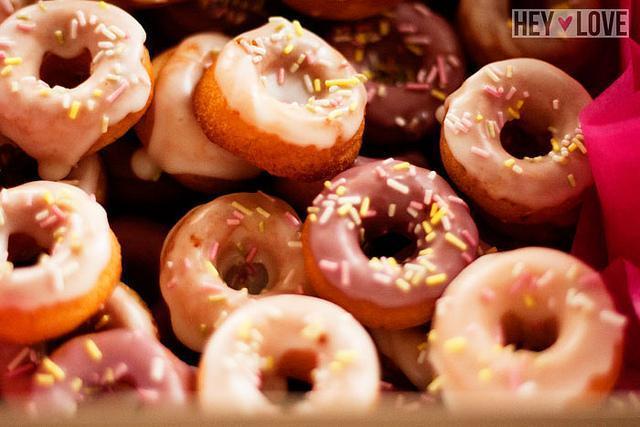How many donuts are there?
Give a very brief answer. 13. 